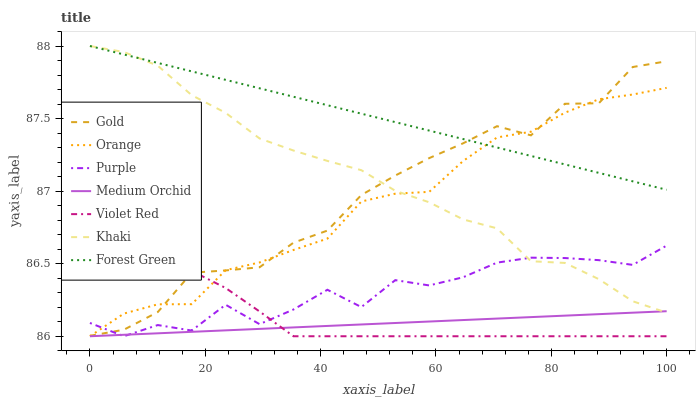Does Khaki have the minimum area under the curve?
Answer yes or no. No. Does Khaki have the maximum area under the curve?
Answer yes or no. No. Is Khaki the smoothest?
Answer yes or no. No. Is Khaki the roughest?
Answer yes or no. No. Does Khaki have the lowest value?
Answer yes or no. No. Does Gold have the highest value?
Answer yes or no. No. Is Purple less than Forest Green?
Answer yes or no. Yes. Is Gold greater than Medium Orchid?
Answer yes or no. Yes. Does Purple intersect Forest Green?
Answer yes or no. No. 